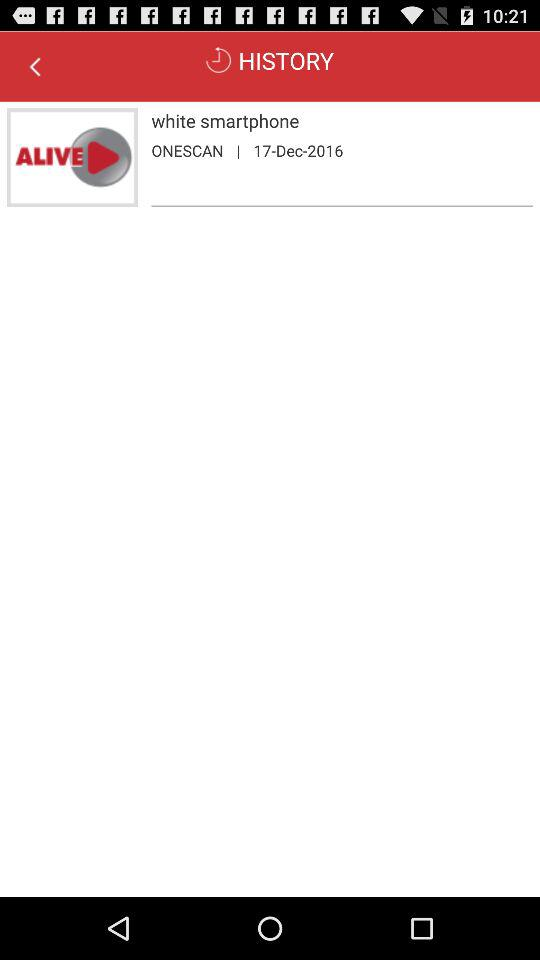What is the given date? The given date is December 17, 2016. 